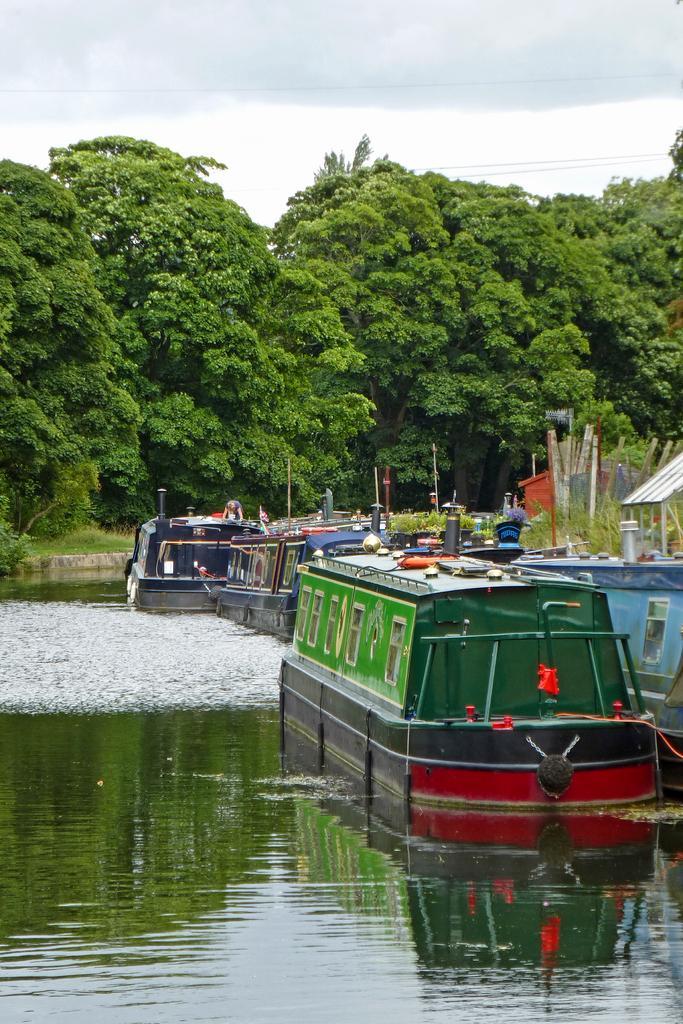Could you give a brief overview of what you see in this image? In this image there is the sky towards the top of the image, there are clouds in the sky, there are wires, there are trees, there is the grass, there is water, there are boats in the water. 